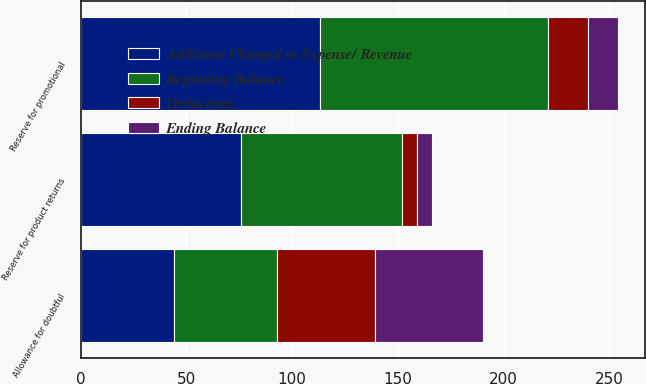Convert chart. <chart><loc_0><loc_0><loc_500><loc_500><stacked_bar_chart><ecel><fcel>Allowance for doubtful<fcel>Reserve for product returns<fcel>Reserve for promotional<nl><fcel>Ending Balance<fcel>51<fcel>7<fcel>14<nl><fcel>Additions Charged to Expense/ Revenue<fcel>44<fcel>76<fcel>113<nl><fcel>Beginning Balance<fcel>49<fcel>76<fcel>108<nl><fcel>Deductions<fcel>46<fcel>7<fcel>19<nl></chart> 